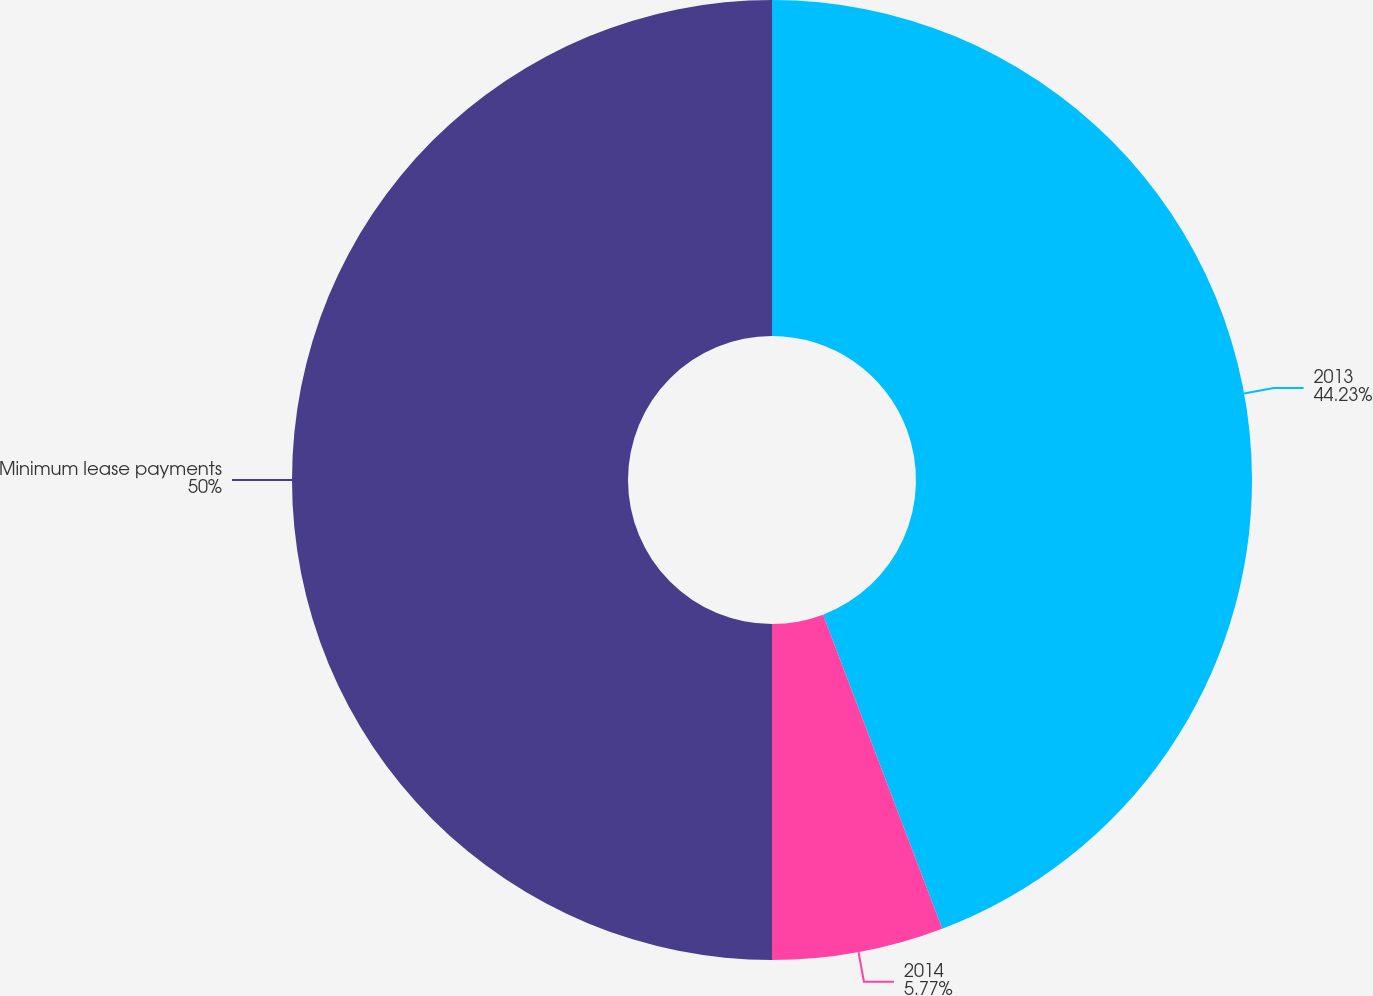Convert chart to OTSL. <chart><loc_0><loc_0><loc_500><loc_500><pie_chart><fcel>2013<fcel>2014<fcel>Minimum lease payments<nl><fcel>44.23%<fcel>5.77%<fcel>50.0%<nl></chart> 